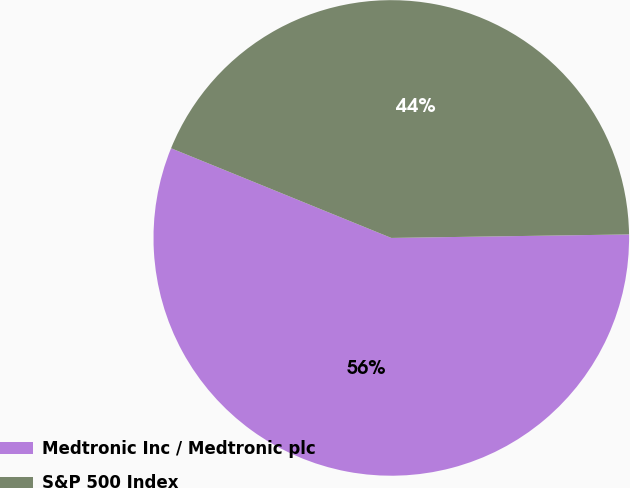<chart> <loc_0><loc_0><loc_500><loc_500><pie_chart><fcel>Medtronic Inc / Medtronic plc<fcel>S&P 500 Index<nl><fcel>56.39%<fcel>43.61%<nl></chart> 